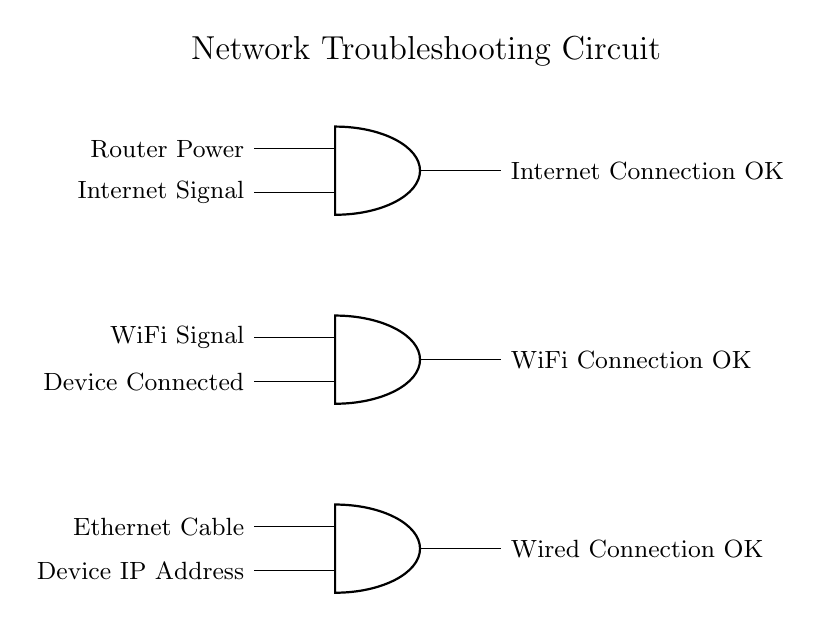What are the inputs for the first AND gate? The first AND gate has two inputs: "Router Power" and "Internet Signal". These inputs are represented by wires connecting from the left side to the gate, indicating that both connections need to be present for the output to be activated.
Answer: Router Power, Internet Signal What output does the second AND gate provide? The second AND gate's output states "WiFi Connection OK", which indicates that both of its inputs must be present for this output to be activated. The inputs are "WiFi Signal" and "Device Connected".
Answer: WiFi Connection OK How many AND gates are in the circuit? There are three AND gates in the circuit diagram, each serving to check different sets of connections for network troubleshooting: the first for router power and internet signal, the second for WiFi signal and device connection, and the third for ethernet cable and device IP address.
Answer: Three What condition is necessary for the "Internet Connection OK" output to be true? For the output "Internet Connection OK" to be true, both inputs to the first AND gate must be true, meaning that the "Router Power" must be supplied and the "Internet Signal" must be present. If either one is absent, the output will be false.
Answer: Router Power and Internet Signal Which device is checked by the third AND gate? The third AND gate checks the connection status for a wired connection, which includes inputs from "Ethernet Cable" and "Device IP Address". If both of these are present, the gate outputs "Wired Connection OK".
Answer: Wired Connection 